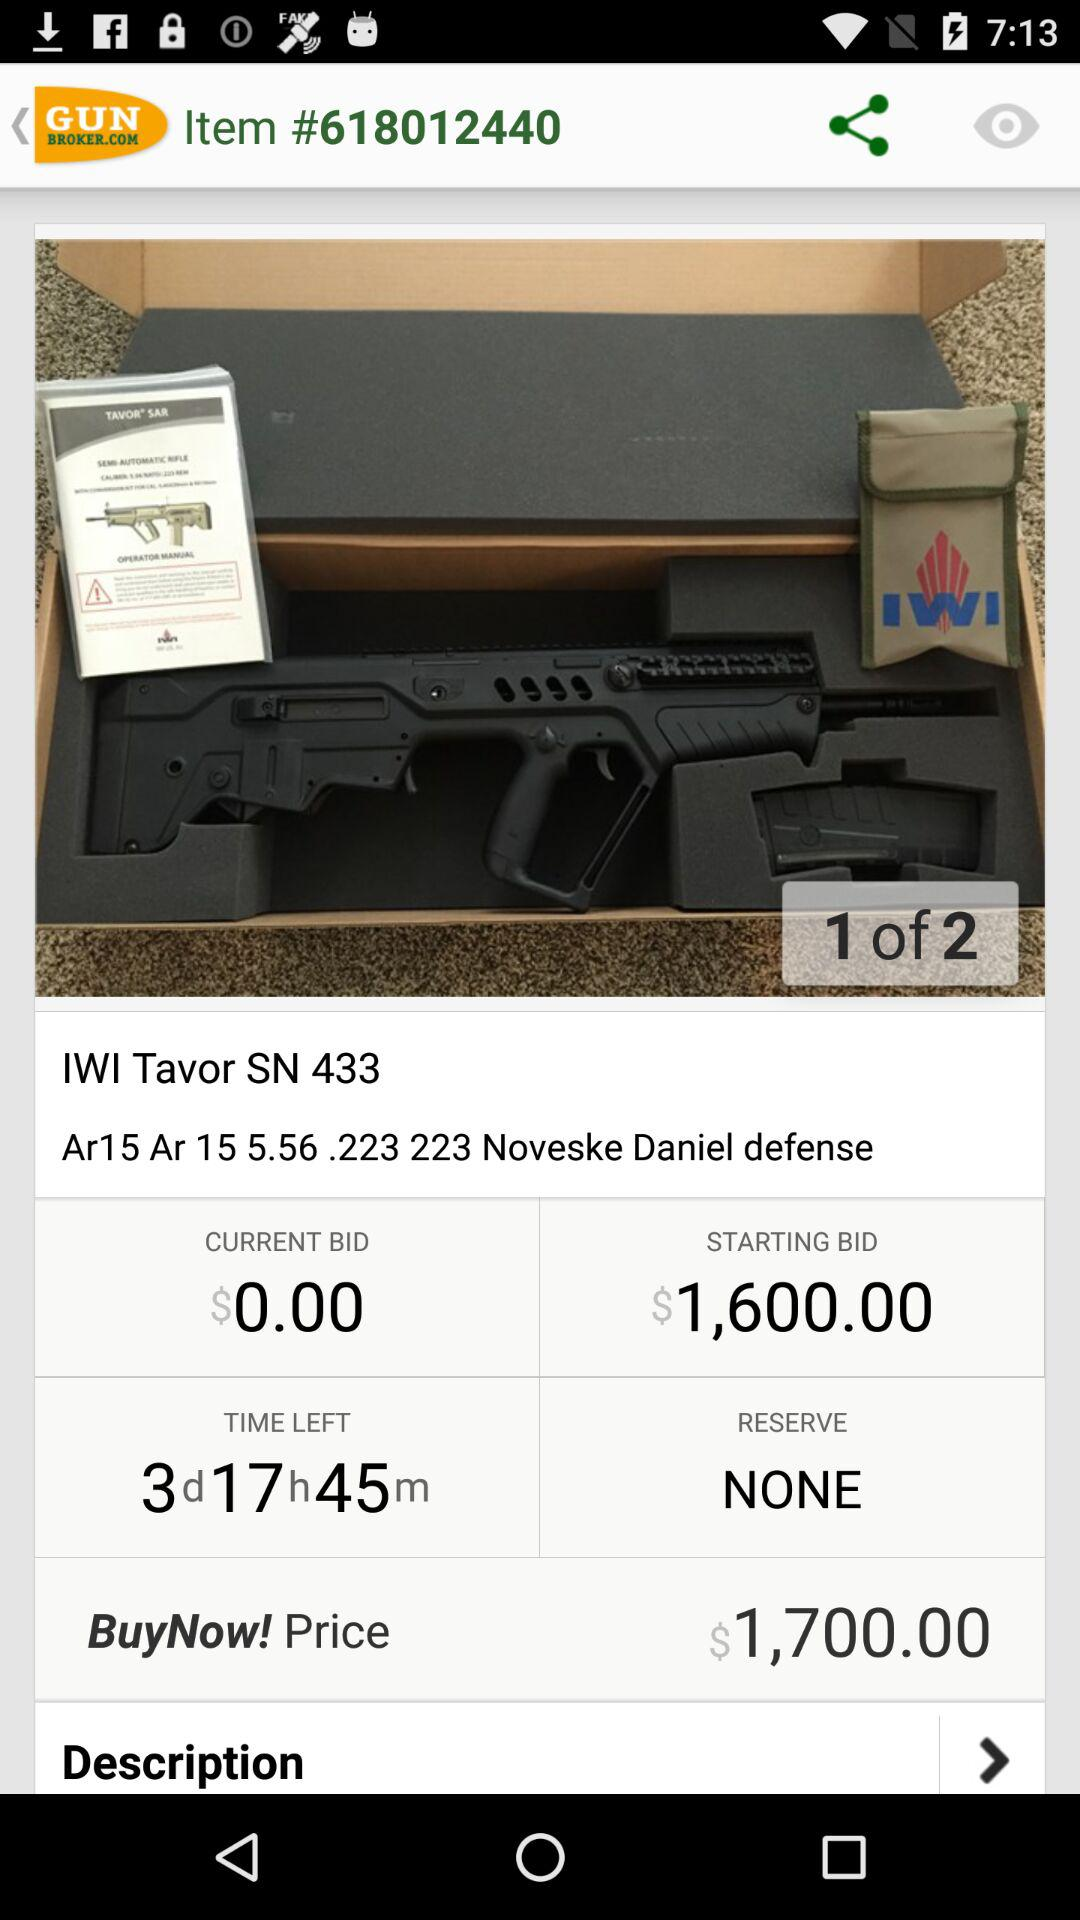What is the buying price? The buying price is $1,700. 